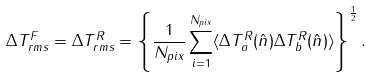Convert formula to latex. <formula><loc_0><loc_0><loc_500><loc_500>\Delta T _ { r m s } ^ { F } = \Delta T _ { r m s } ^ { R } = \left \{ \frac { 1 } { N _ { p i x } } \sum _ { i = 1 } ^ { N _ { p i x } } \langle \Delta T ^ { R } _ { a } ( \hat { n } ) \Delta T ^ { R } _ { b } ( \hat { n } ) \rangle \right \} ^ { \frac { 1 } { 2 } } .</formula> 